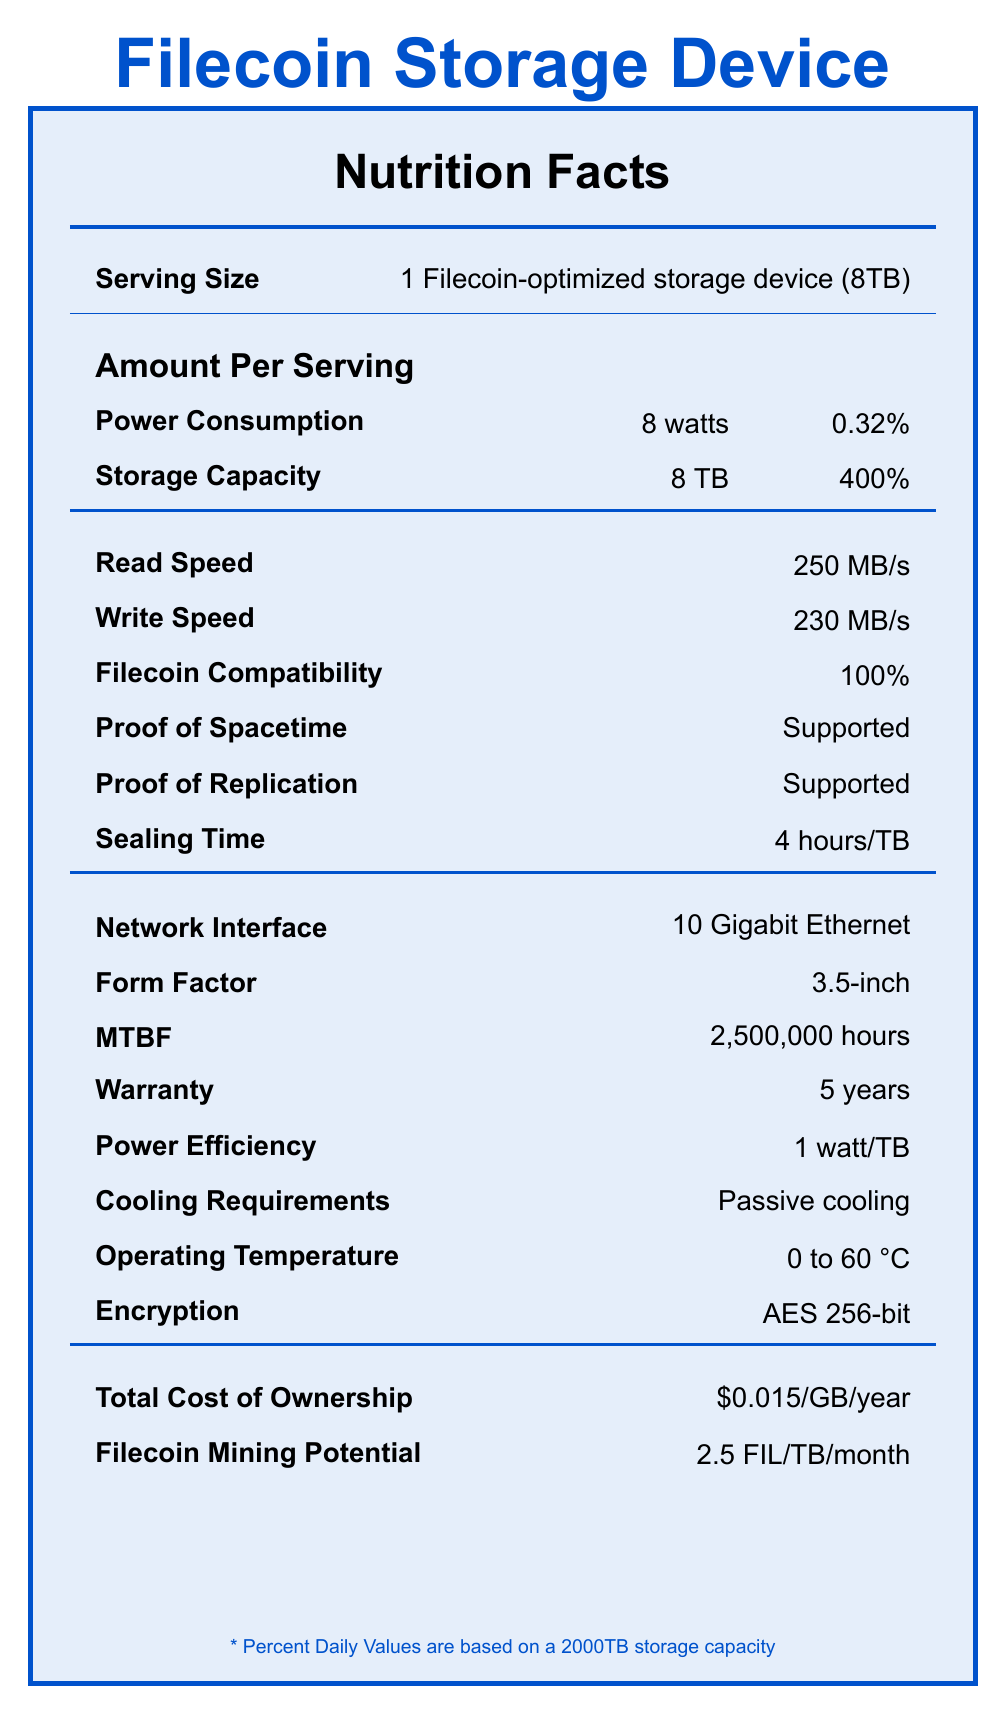what is the serving size for the storage device? The serving size is clearly stated as 1 Filecoin-optimized storage device (8TB).
Answer: 1 Filecoin-optimized storage device (8TB) what is the daily value percentage of power consumption? The daily value percentage for power consumption is listed as 0.32%.
Answer: 0.32% what is the read speed of the storage device? The read speed is specified as 250 MB/s in the document.
Answer: 250 MB/s what encryption standard does the storage device use? The document notes that the encryption standard is AES 256-bit.
Answer: AES 256-bit how long is the warranty for this storage device? The warranty for the storage device is listed as 5 years.
Answer: 5 years what is the power efficiency of the storage device? The power efficiency is noted as 1 watt/TB in the document.
Answer: 1 watt/TB what is the sealing time for storing data on the device? A. 1 hour/TB B. 2 hours/TB C. 4 hours/TB D. 8 hours/TB The sealing time is listed as 4 hours/TB.
Answer: C. 4 hours/TB what network interface is supported by the storage device? A. 1 Gigabit Ethernet B. 10 Gigabit Ethernet C. 100 Gigabit Ethernet D. Wi-Fi The document states that the network interface is 10 Gigabit Ethernet.
Answer: B. 10 Gigabit Ethernet is the storage device compatible with Filecoin? The document mentions that the Filecoin compatibility is 100%, indicating full compatibility.
Answer: Yes summarize the main details of the storage device presented in the document. The document provides an overview and detailed specifications of a Filecoin-optimized storage device including performance, power, compatibility, and usage metrics.
Answer: The document details the specifications of a Filecoin-optimized storage device with 8TB capacity. It discusses aspects like power consumption (8 watts), power efficiency (1 watt/TB), encryption (AES 256-bit), and warranty (5 years). It also covers performance metrics such as read speed (250 MB/s) and write speed (230 MB/s), and features related to Filecoin mining, such as 2.5 FIL/TB/month mining potential. Additionally, the device supports proof of spacetime, proof of replication, and has a sealing time of 4 hours per TB. what is the price of the storage device? The document does not provide the price of the storage device.
Answer: Cannot be determined what is the total cost of ownership for this storage device? The document specifies the total cost of ownership as $0.015 per GB per year.
Answer: $0.015/GB/year what is the Filecoin mining potential of the storage device? The document indicates that the Filecoin mining potential is 2.5 FIL per TB per month.
Answer: 2.5 FIL/TB/month what are the cooling requirements for the storage device? The cooling requirements are listed as passive cooling in the document.
Answer: Passive cooling what temperature range can the storage device operate within? The operating temperature range is specified as 0 to 60 °C in the document.
Answer: 0 to 60 °C what is the mean time between failures (MTBF) for the storage device? The MTBF for the storage device is listed as 2,500,000 hours.
Answer: 2,500,000 hours 